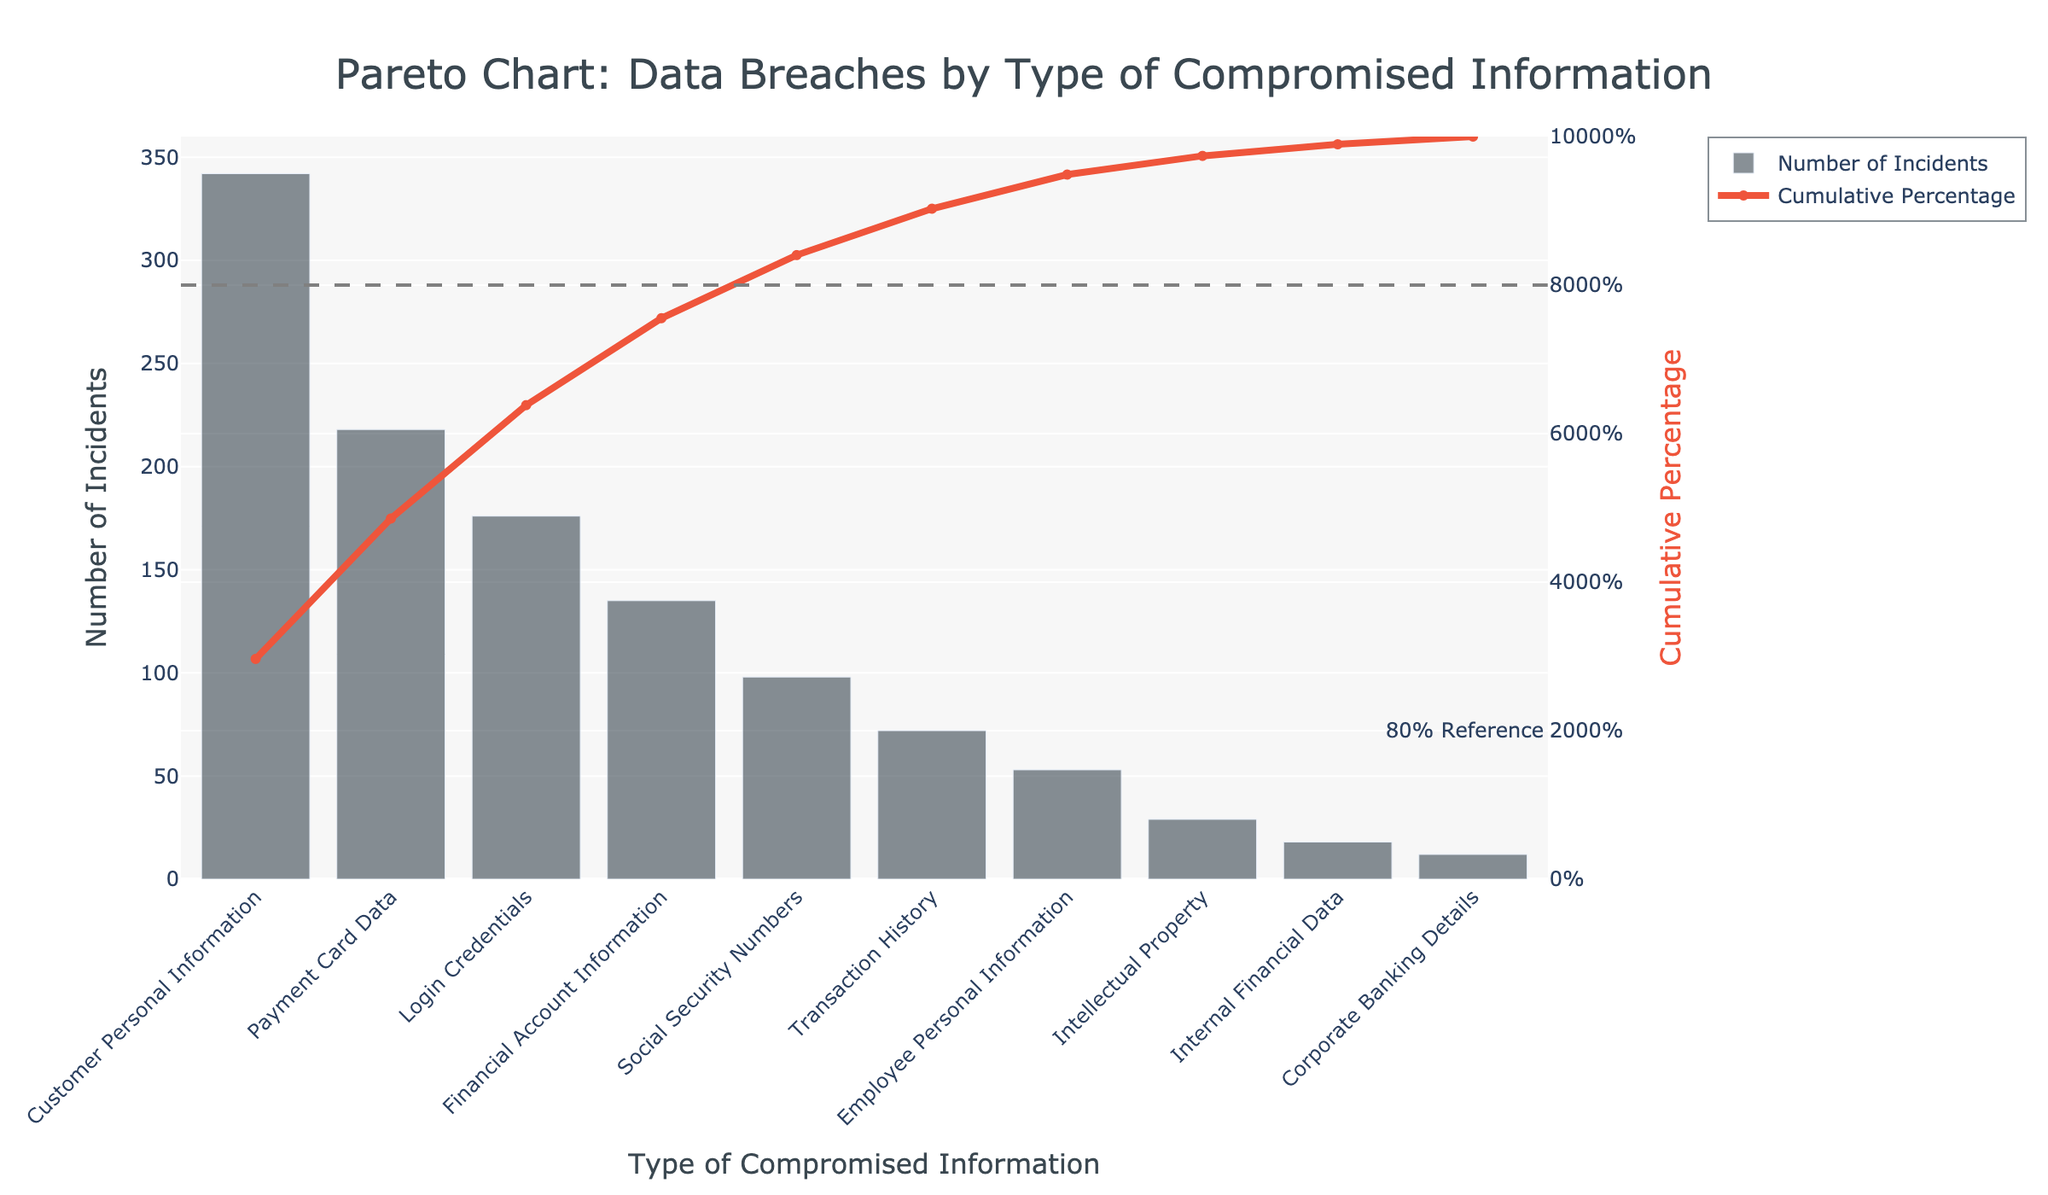What is the title of the chart? The title of the chart is typically located at the top. It reads "Pareto Chart: Data Breaches by Type of Compromised Information".
Answer: Pareto Chart: Data Breaches by Type of Compromised Information Which type of compromised information has the highest number of incidents? The bar representing "Customer Personal Information" is the tallest, indicating it has the highest number of incidents.
Answer: Customer Personal Information What cumulative percentage do the top three types of compromised information contribute to? Add the number of incidents for the top three types: 342 (Customer Personal Information), 218 (Payment Card Data), and 176 (Login Credentials). The total is 342 + 218 + 176 = 736. The overall incidents sum is 1353. Therefore, the cumulative percentage is (736/1353) * 100, which is approximately 54.39%.
Answer: Approximately 54.39% Which type of compromised information marks the crossover point of the 80% cumulative percentage line? Look at the cumulative percentage line intersecting the 80% reference line. The type just before or at this crossover point is "Social Security Numbers".
Answer: Social Security Numbers What is the difference in the number of incidents between the types with the highest and lowest number of incidents? Subtract the number of incidents of "Corporate Banking Details" (12) from "Customer Personal Information" (342). The difference is 342 - 12 = 330.
Answer: 330 Which are the top five types of compromised information in terms of the number of incidents? The top five types according to the descending order of bar height are "Customer Personal Information" (342), "Payment Card Data" (218), "Login Credentials" (176), "Financial Account Information" (135), and "Social Security Numbers" (98).
Answer: Customer Personal Information, Payment Card Data, Login Credentials, Financial Account Information, Social Security Numbers Is the number of incidents for "Employee Personal Information" higher or lower than "Transaction History"? By comparing the height of the bars, "Employee Personal Information" (53) is lower than "Transaction History" (72).
Answer: Lower How many types of compromised information have fewer than 100 incidents? Count the number of bars that have heights representing fewer than 100 incidents. These are "Transaction History" (72), "Employee Personal Information" (53), "Intellectual Property" (29), "Internal Financial Data" (18), and "Corporate Banking Details" (12). There are 5 types.
Answer: 5 What are the colors of the bar and line charts? The bar chart bars have a dark gray color, and the line chart line is red. This can be deduced from the visual appearance of the figure.
Answer: Dark gray (bar), Red (line) 